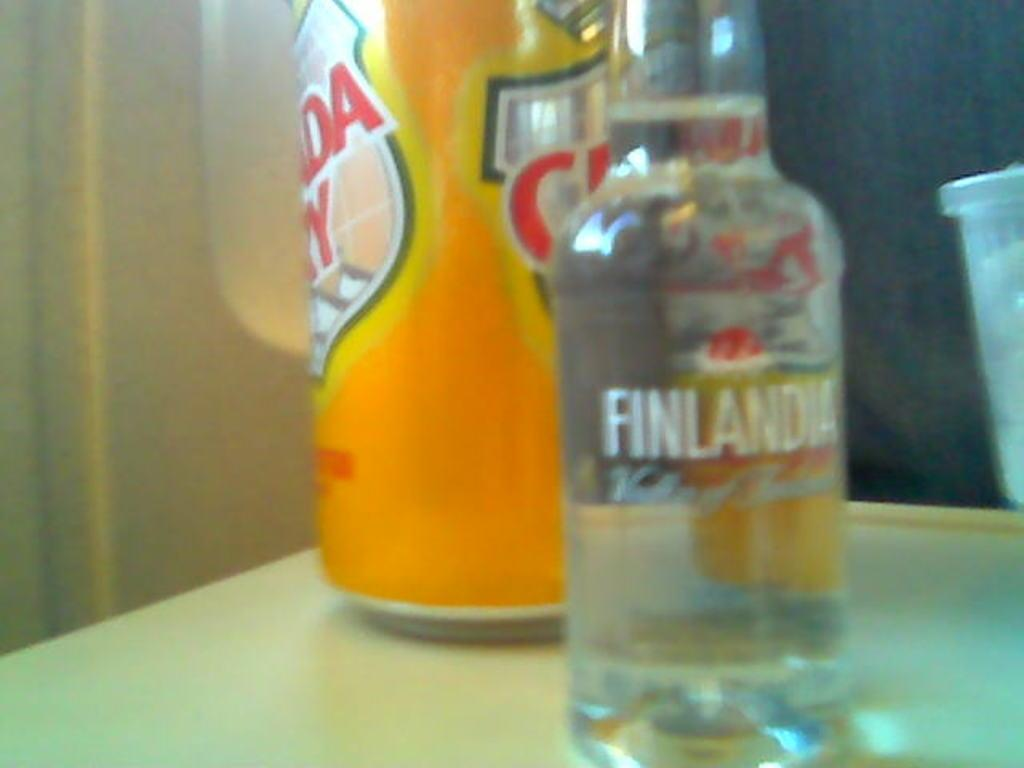<image>
Create a compact narrative representing the image presented. A can of canada dry siting next to a bottle of finlandia 